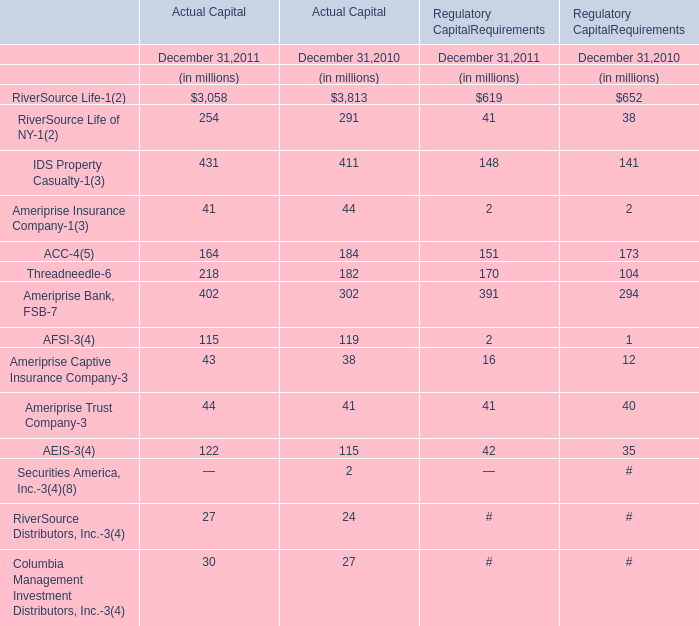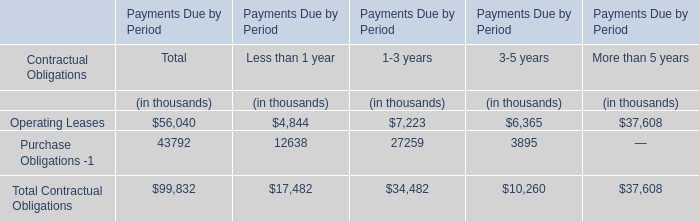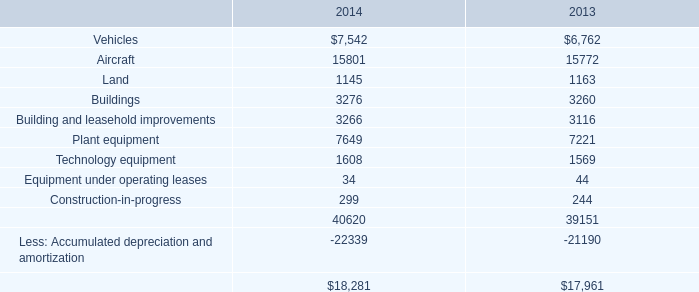What is the sum of Purchase Obligations -1 of Less than 1 year for Payments Due by Period and Aircraft in 2014? (in thousand) 
Computations: (12638 + 15801)
Answer: 28439.0. 